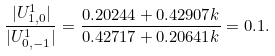Convert formula to latex. <formula><loc_0><loc_0><loc_500><loc_500>\frac { | U _ { 1 , 0 } ^ { 1 } | } { | U _ { 0 , - 1 } ^ { 1 } | } = \frac { 0 . 2 0 2 4 4 + 0 . 4 2 9 0 7 k } { 0 . 4 2 7 1 7 + 0 . 2 0 6 4 1 k } = 0 . 1 .</formula> 